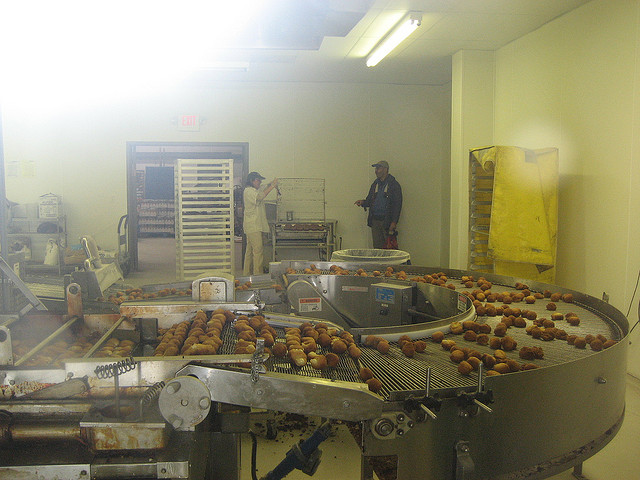<image>Is this a canning factory? It is not clear if this is a canning factory. However, the majority suggests it is not. Is this a canning factory? I am not sure if this is a canning factory. It can be seen that it is not a canning factory, but I cannot be certain. 